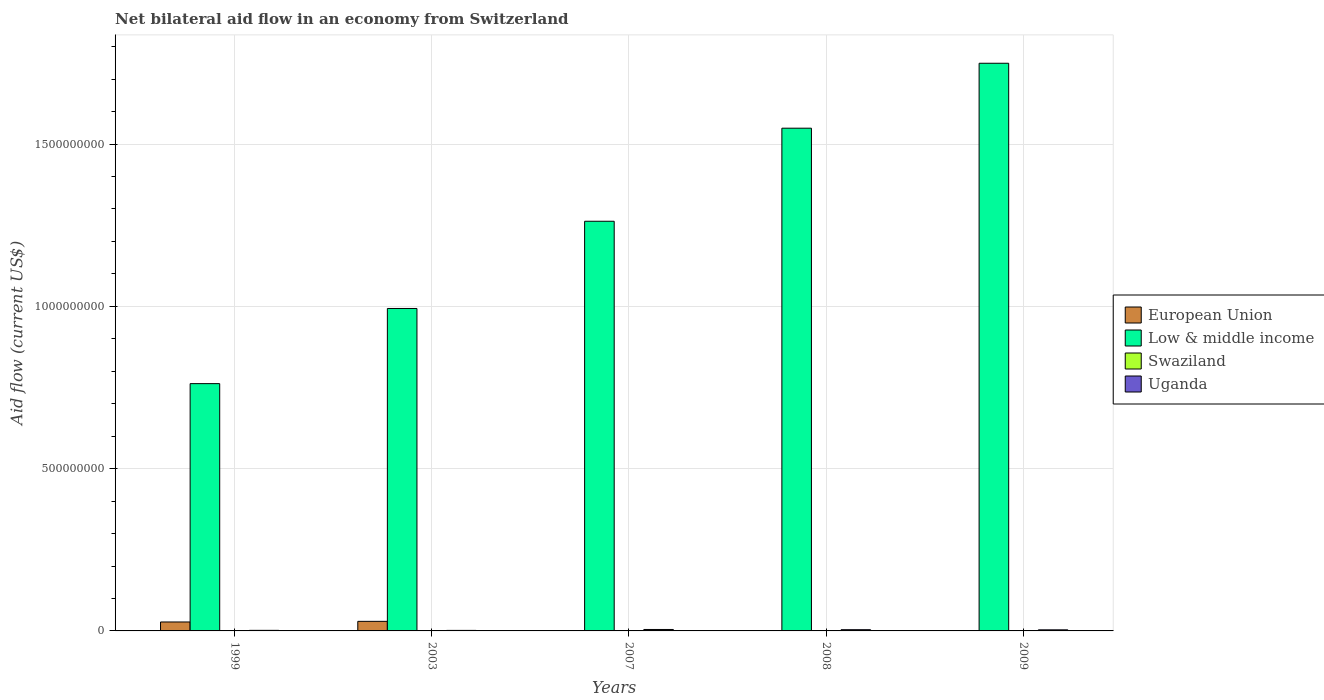Are the number of bars per tick equal to the number of legend labels?
Offer a terse response. Yes. Are the number of bars on each tick of the X-axis equal?
Offer a very short reply. Yes. How many bars are there on the 5th tick from the left?
Offer a very short reply. 4. In how many cases, is the number of bars for a given year not equal to the number of legend labels?
Ensure brevity in your answer.  0. Across all years, what is the maximum net bilateral aid flow in Low & middle income?
Keep it short and to the point. 1.75e+09. In which year was the net bilateral aid flow in Swaziland maximum?
Provide a succinct answer. 2008. What is the total net bilateral aid flow in Low & middle income in the graph?
Offer a very short reply. 6.32e+09. What is the difference between the net bilateral aid flow in Uganda in 2008 and that in 2009?
Give a very brief answer. 4.20e+05. What is the difference between the net bilateral aid flow in Low & middle income in 2003 and the net bilateral aid flow in Swaziland in 1999?
Ensure brevity in your answer.  9.93e+08. What is the average net bilateral aid flow in Low & middle income per year?
Keep it short and to the point. 1.26e+09. In the year 1999, what is the difference between the net bilateral aid flow in European Union and net bilateral aid flow in Uganda?
Make the answer very short. 2.58e+07. What is the ratio of the net bilateral aid flow in European Union in 1999 to that in 2007?
Offer a terse response. 306.33. Is the difference between the net bilateral aid flow in European Union in 1999 and 2008 greater than the difference between the net bilateral aid flow in Uganda in 1999 and 2008?
Offer a very short reply. Yes. What is the difference between the highest and the second highest net bilateral aid flow in Uganda?
Provide a short and direct response. 6.80e+05. What is the difference between the highest and the lowest net bilateral aid flow in Low & middle income?
Keep it short and to the point. 9.87e+08. In how many years, is the net bilateral aid flow in European Union greater than the average net bilateral aid flow in European Union taken over all years?
Offer a terse response. 2. Is the sum of the net bilateral aid flow in European Union in 2008 and 2009 greater than the maximum net bilateral aid flow in Low & middle income across all years?
Make the answer very short. No. What does the 3rd bar from the left in 2007 represents?
Offer a very short reply. Swaziland. What does the 1st bar from the right in 2009 represents?
Your answer should be compact. Uganda. Is it the case that in every year, the sum of the net bilateral aid flow in European Union and net bilateral aid flow in Swaziland is greater than the net bilateral aid flow in Uganda?
Offer a very short reply. No. How many bars are there?
Ensure brevity in your answer.  20. How many years are there in the graph?
Your answer should be compact. 5. What is the difference between two consecutive major ticks on the Y-axis?
Give a very brief answer. 5.00e+08. Does the graph contain grids?
Give a very brief answer. Yes. How many legend labels are there?
Your answer should be compact. 4. How are the legend labels stacked?
Offer a terse response. Vertical. What is the title of the graph?
Provide a short and direct response. Net bilateral aid flow in an economy from Switzerland. Does "Macedonia" appear as one of the legend labels in the graph?
Provide a succinct answer. No. What is the label or title of the Y-axis?
Provide a succinct answer. Aid flow (current US$). What is the Aid flow (current US$) in European Union in 1999?
Provide a succinct answer. 2.76e+07. What is the Aid flow (current US$) in Low & middle income in 1999?
Offer a terse response. 7.62e+08. What is the Aid flow (current US$) of Uganda in 1999?
Offer a terse response. 1.77e+06. What is the Aid flow (current US$) of European Union in 2003?
Provide a succinct answer. 2.95e+07. What is the Aid flow (current US$) of Low & middle income in 2003?
Your answer should be very brief. 9.93e+08. What is the Aid flow (current US$) in Uganda in 2003?
Your answer should be very brief. 1.62e+06. What is the Aid flow (current US$) in European Union in 2007?
Ensure brevity in your answer.  9.00e+04. What is the Aid flow (current US$) of Low & middle income in 2007?
Keep it short and to the point. 1.26e+09. What is the Aid flow (current US$) in Uganda in 2007?
Your answer should be compact. 4.44e+06. What is the Aid flow (current US$) in Low & middle income in 2008?
Give a very brief answer. 1.55e+09. What is the Aid flow (current US$) of Uganda in 2008?
Your answer should be very brief. 3.76e+06. What is the Aid flow (current US$) in European Union in 2009?
Provide a succinct answer. 8.00e+04. What is the Aid flow (current US$) of Low & middle income in 2009?
Your answer should be compact. 1.75e+09. What is the Aid flow (current US$) of Uganda in 2009?
Make the answer very short. 3.34e+06. Across all years, what is the maximum Aid flow (current US$) of European Union?
Your answer should be compact. 2.95e+07. Across all years, what is the maximum Aid flow (current US$) in Low & middle income?
Ensure brevity in your answer.  1.75e+09. Across all years, what is the maximum Aid flow (current US$) in Swaziland?
Give a very brief answer. 1.40e+05. Across all years, what is the maximum Aid flow (current US$) in Uganda?
Provide a succinct answer. 4.44e+06. Across all years, what is the minimum Aid flow (current US$) of European Union?
Provide a short and direct response. 8.00e+04. Across all years, what is the minimum Aid flow (current US$) of Low & middle income?
Your answer should be very brief. 7.62e+08. Across all years, what is the minimum Aid flow (current US$) in Swaziland?
Provide a succinct answer. 2.00e+04. Across all years, what is the minimum Aid flow (current US$) in Uganda?
Your answer should be compact. 1.62e+06. What is the total Aid flow (current US$) in European Union in the graph?
Keep it short and to the point. 5.74e+07. What is the total Aid flow (current US$) in Low & middle income in the graph?
Ensure brevity in your answer.  6.32e+09. What is the total Aid flow (current US$) in Swaziland in the graph?
Offer a terse response. 2.90e+05. What is the total Aid flow (current US$) in Uganda in the graph?
Keep it short and to the point. 1.49e+07. What is the difference between the Aid flow (current US$) in European Union in 1999 and that in 2003?
Your answer should be compact. -1.92e+06. What is the difference between the Aid flow (current US$) of Low & middle income in 1999 and that in 2003?
Your answer should be compact. -2.32e+08. What is the difference between the Aid flow (current US$) in European Union in 1999 and that in 2007?
Give a very brief answer. 2.75e+07. What is the difference between the Aid flow (current US$) of Low & middle income in 1999 and that in 2007?
Offer a very short reply. -5.00e+08. What is the difference between the Aid flow (current US$) of Uganda in 1999 and that in 2007?
Give a very brief answer. -2.67e+06. What is the difference between the Aid flow (current US$) of European Union in 1999 and that in 2008?
Give a very brief answer. 2.74e+07. What is the difference between the Aid flow (current US$) in Low & middle income in 1999 and that in 2008?
Provide a succinct answer. -7.87e+08. What is the difference between the Aid flow (current US$) of Swaziland in 1999 and that in 2008?
Provide a succinct answer. -1.00e+05. What is the difference between the Aid flow (current US$) of Uganda in 1999 and that in 2008?
Your answer should be very brief. -1.99e+06. What is the difference between the Aid flow (current US$) of European Union in 1999 and that in 2009?
Give a very brief answer. 2.75e+07. What is the difference between the Aid flow (current US$) of Low & middle income in 1999 and that in 2009?
Your answer should be compact. -9.87e+08. What is the difference between the Aid flow (current US$) in Swaziland in 1999 and that in 2009?
Your answer should be very brief. 2.00e+04. What is the difference between the Aid flow (current US$) in Uganda in 1999 and that in 2009?
Make the answer very short. -1.57e+06. What is the difference between the Aid flow (current US$) of European Union in 2003 and that in 2007?
Give a very brief answer. 2.94e+07. What is the difference between the Aid flow (current US$) of Low & middle income in 2003 and that in 2007?
Your answer should be very brief. -2.69e+08. What is the difference between the Aid flow (current US$) in Uganda in 2003 and that in 2007?
Offer a terse response. -2.82e+06. What is the difference between the Aid flow (current US$) in European Union in 2003 and that in 2008?
Keep it short and to the point. 2.94e+07. What is the difference between the Aid flow (current US$) of Low & middle income in 2003 and that in 2008?
Make the answer very short. -5.55e+08. What is the difference between the Aid flow (current US$) in Uganda in 2003 and that in 2008?
Keep it short and to the point. -2.14e+06. What is the difference between the Aid flow (current US$) of European Union in 2003 and that in 2009?
Your answer should be compact. 2.94e+07. What is the difference between the Aid flow (current US$) in Low & middle income in 2003 and that in 2009?
Offer a terse response. -7.56e+08. What is the difference between the Aid flow (current US$) of Uganda in 2003 and that in 2009?
Provide a short and direct response. -1.72e+06. What is the difference between the Aid flow (current US$) in Low & middle income in 2007 and that in 2008?
Your response must be concise. -2.87e+08. What is the difference between the Aid flow (current US$) in Swaziland in 2007 and that in 2008?
Ensure brevity in your answer.  -1.20e+05. What is the difference between the Aid flow (current US$) of Uganda in 2007 and that in 2008?
Your answer should be very brief. 6.80e+05. What is the difference between the Aid flow (current US$) of Low & middle income in 2007 and that in 2009?
Give a very brief answer. -4.87e+08. What is the difference between the Aid flow (current US$) of Swaziland in 2007 and that in 2009?
Provide a succinct answer. 0. What is the difference between the Aid flow (current US$) in Uganda in 2007 and that in 2009?
Ensure brevity in your answer.  1.10e+06. What is the difference between the Aid flow (current US$) in European Union in 2008 and that in 2009?
Provide a succinct answer. 5.00e+04. What is the difference between the Aid flow (current US$) of Low & middle income in 2008 and that in 2009?
Make the answer very short. -2.00e+08. What is the difference between the Aid flow (current US$) of Swaziland in 2008 and that in 2009?
Your response must be concise. 1.20e+05. What is the difference between the Aid flow (current US$) of European Union in 1999 and the Aid flow (current US$) of Low & middle income in 2003?
Keep it short and to the point. -9.66e+08. What is the difference between the Aid flow (current US$) in European Union in 1999 and the Aid flow (current US$) in Swaziland in 2003?
Your answer should be very brief. 2.75e+07. What is the difference between the Aid flow (current US$) in European Union in 1999 and the Aid flow (current US$) in Uganda in 2003?
Keep it short and to the point. 2.60e+07. What is the difference between the Aid flow (current US$) of Low & middle income in 1999 and the Aid flow (current US$) of Swaziland in 2003?
Your answer should be compact. 7.62e+08. What is the difference between the Aid flow (current US$) in Low & middle income in 1999 and the Aid flow (current US$) in Uganda in 2003?
Your response must be concise. 7.60e+08. What is the difference between the Aid flow (current US$) of Swaziland in 1999 and the Aid flow (current US$) of Uganda in 2003?
Offer a terse response. -1.58e+06. What is the difference between the Aid flow (current US$) of European Union in 1999 and the Aid flow (current US$) of Low & middle income in 2007?
Ensure brevity in your answer.  -1.23e+09. What is the difference between the Aid flow (current US$) of European Union in 1999 and the Aid flow (current US$) of Swaziland in 2007?
Make the answer very short. 2.76e+07. What is the difference between the Aid flow (current US$) of European Union in 1999 and the Aid flow (current US$) of Uganda in 2007?
Offer a very short reply. 2.31e+07. What is the difference between the Aid flow (current US$) in Low & middle income in 1999 and the Aid flow (current US$) in Swaziland in 2007?
Keep it short and to the point. 7.62e+08. What is the difference between the Aid flow (current US$) of Low & middle income in 1999 and the Aid flow (current US$) of Uganda in 2007?
Offer a very short reply. 7.57e+08. What is the difference between the Aid flow (current US$) of Swaziland in 1999 and the Aid flow (current US$) of Uganda in 2007?
Provide a succinct answer. -4.40e+06. What is the difference between the Aid flow (current US$) in European Union in 1999 and the Aid flow (current US$) in Low & middle income in 2008?
Your answer should be compact. -1.52e+09. What is the difference between the Aid flow (current US$) in European Union in 1999 and the Aid flow (current US$) in Swaziland in 2008?
Give a very brief answer. 2.74e+07. What is the difference between the Aid flow (current US$) in European Union in 1999 and the Aid flow (current US$) in Uganda in 2008?
Your answer should be compact. 2.38e+07. What is the difference between the Aid flow (current US$) in Low & middle income in 1999 and the Aid flow (current US$) in Swaziland in 2008?
Give a very brief answer. 7.62e+08. What is the difference between the Aid flow (current US$) in Low & middle income in 1999 and the Aid flow (current US$) in Uganda in 2008?
Provide a succinct answer. 7.58e+08. What is the difference between the Aid flow (current US$) in Swaziland in 1999 and the Aid flow (current US$) in Uganda in 2008?
Provide a succinct answer. -3.72e+06. What is the difference between the Aid flow (current US$) in European Union in 1999 and the Aid flow (current US$) in Low & middle income in 2009?
Provide a short and direct response. -1.72e+09. What is the difference between the Aid flow (current US$) of European Union in 1999 and the Aid flow (current US$) of Swaziland in 2009?
Your response must be concise. 2.76e+07. What is the difference between the Aid flow (current US$) of European Union in 1999 and the Aid flow (current US$) of Uganda in 2009?
Your response must be concise. 2.42e+07. What is the difference between the Aid flow (current US$) in Low & middle income in 1999 and the Aid flow (current US$) in Swaziland in 2009?
Your answer should be very brief. 7.62e+08. What is the difference between the Aid flow (current US$) in Low & middle income in 1999 and the Aid flow (current US$) in Uganda in 2009?
Make the answer very short. 7.59e+08. What is the difference between the Aid flow (current US$) in Swaziland in 1999 and the Aid flow (current US$) in Uganda in 2009?
Make the answer very short. -3.30e+06. What is the difference between the Aid flow (current US$) of European Union in 2003 and the Aid flow (current US$) of Low & middle income in 2007?
Your answer should be very brief. -1.23e+09. What is the difference between the Aid flow (current US$) in European Union in 2003 and the Aid flow (current US$) in Swaziland in 2007?
Your answer should be very brief. 2.95e+07. What is the difference between the Aid flow (current US$) of European Union in 2003 and the Aid flow (current US$) of Uganda in 2007?
Offer a very short reply. 2.50e+07. What is the difference between the Aid flow (current US$) in Low & middle income in 2003 and the Aid flow (current US$) in Swaziland in 2007?
Keep it short and to the point. 9.93e+08. What is the difference between the Aid flow (current US$) in Low & middle income in 2003 and the Aid flow (current US$) in Uganda in 2007?
Offer a terse response. 9.89e+08. What is the difference between the Aid flow (current US$) in Swaziland in 2003 and the Aid flow (current US$) in Uganda in 2007?
Give a very brief answer. -4.37e+06. What is the difference between the Aid flow (current US$) in European Union in 2003 and the Aid flow (current US$) in Low & middle income in 2008?
Your answer should be compact. -1.52e+09. What is the difference between the Aid flow (current US$) in European Union in 2003 and the Aid flow (current US$) in Swaziland in 2008?
Make the answer very short. 2.94e+07. What is the difference between the Aid flow (current US$) of European Union in 2003 and the Aid flow (current US$) of Uganda in 2008?
Your answer should be compact. 2.57e+07. What is the difference between the Aid flow (current US$) in Low & middle income in 2003 and the Aid flow (current US$) in Swaziland in 2008?
Offer a very short reply. 9.93e+08. What is the difference between the Aid flow (current US$) of Low & middle income in 2003 and the Aid flow (current US$) of Uganda in 2008?
Give a very brief answer. 9.90e+08. What is the difference between the Aid flow (current US$) in Swaziland in 2003 and the Aid flow (current US$) in Uganda in 2008?
Make the answer very short. -3.69e+06. What is the difference between the Aid flow (current US$) of European Union in 2003 and the Aid flow (current US$) of Low & middle income in 2009?
Offer a terse response. -1.72e+09. What is the difference between the Aid flow (current US$) of European Union in 2003 and the Aid flow (current US$) of Swaziland in 2009?
Provide a succinct answer. 2.95e+07. What is the difference between the Aid flow (current US$) of European Union in 2003 and the Aid flow (current US$) of Uganda in 2009?
Offer a very short reply. 2.62e+07. What is the difference between the Aid flow (current US$) of Low & middle income in 2003 and the Aid flow (current US$) of Swaziland in 2009?
Ensure brevity in your answer.  9.93e+08. What is the difference between the Aid flow (current US$) of Low & middle income in 2003 and the Aid flow (current US$) of Uganda in 2009?
Make the answer very short. 9.90e+08. What is the difference between the Aid flow (current US$) of Swaziland in 2003 and the Aid flow (current US$) of Uganda in 2009?
Offer a very short reply. -3.27e+06. What is the difference between the Aid flow (current US$) in European Union in 2007 and the Aid flow (current US$) in Low & middle income in 2008?
Offer a terse response. -1.55e+09. What is the difference between the Aid flow (current US$) of European Union in 2007 and the Aid flow (current US$) of Uganda in 2008?
Your answer should be compact. -3.67e+06. What is the difference between the Aid flow (current US$) in Low & middle income in 2007 and the Aid flow (current US$) in Swaziland in 2008?
Provide a succinct answer. 1.26e+09. What is the difference between the Aid flow (current US$) of Low & middle income in 2007 and the Aid flow (current US$) of Uganda in 2008?
Keep it short and to the point. 1.26e+09. What is the difference between the Aid flow (current US$) in Swaziland in 2007 and the Aid flow (current US$) in Uganda in 2008?
Give a very brief answer. -3.74e+06. What is the difference between the Aid flow (current US$) of European Union in 2007 and the Aid flow (current US$) of Low & middle income in 2009?
Your answer should be very brief. -1.75e+09. What is the difference between the Aid flow (current US$) of European Union in 2007 and the Aid flow (current US$) of Uganda in 2009?
Provide a short and direct response. -3.25e+06. What is the difference between the Aid flow (current US$) in Low & middle income in 2007 and the Aid flow (current US$) in Swaziland in 2009?
Offer a very short reply. 1.26e+09. What is the difference between the Aid flow (current US$) of Low & middle income in 2007 and the Aid flow (current US$) of Uganda in 2009?
Give a very brief answer. 1.26e+09. What is the difference between the Aid flow (current US$) in Swaziland in 2007 and the Aid flow (current US$) in Uganda in 2009?
Keep it short and to the point. -3.32e+06. What is the difference between the Aid flow (current US$) in European Union in 2008 and the Aid flow (current US$) in Low & middle income in 2009?
Your answer should be very brief. -1.75e+09. What is the difference between the Aid flow (current US$) of European Union in 2008 and the Aid flow (current US$) of Swaziland in 2009?
Your answer should be compact. 1.10e+05. What is the difference between the Aid flow (current US$) of European Union in 2008 and the Aid flow (current US$) of Uganda in 2009?
Offer a very short reply. -3.21e+06. What is the difference between the Aid flow (current US$) in Low & middle income in 2008 and the Aid flow (current US$) in Swaziland in 2009?
Offer a terse response. 1.55e+09. What is the difference between the Aid flow (current US$) in Low & middle income in 2008 and the Aid flow (current US$) in Uganda in 2009?
Your answer should be compact. 1.55e+09. What is the difference between the Aid flow (current US$) of Swaziland in 2008 and the Aid flow (current US$) of Uganda in 2009?
Give a very brief answer. -3.20e+06. What is the average Aid flow (current US$) of European Union per year?
Provide a succinct answer. 1.15e+07. What is the average Aid flow (current US$) in Low & middle income per year?
Your answer should be very brief. 1.26e+09. What is the average Aid flow (current US$) in Swaziland per year?
Make the answer very short. 5.80e+04. What is the average Aid flow (current US$) in Uganda per year?
Ensure brevity in your answer.  2.99e+06. In the year 1999, what is the difference between the Aid flow (current US$) in European Union and Aid flow (current US$) in Low & middle income?
Your answer should be very brief. -7.34e+08. In the year 1999, what is the difference between the Aid flow (current US$) of European Union and Aid flow (current US$) of Swaziland?
Ensure brevity in your answer.  2.75e+07. In the year 1999, what is the difference between the Aid flow (current US$) in European Union and Aid flow (current US$) in Uganda?
Ensure brevity in your answer.  2.58e+07. In the year 1999, what is the difference between the Aid flow (current US$) of Low & middle income and Aid flow (current US$) of Swaziland?
Keep it short and to the point. 7.62e+08. In the year 1999, what is the difference between the Aid flow (current US$) in Low & middle income and Aid flow (current US$) in Uganda?
Provide a short and direct response. 7.60e+08. In the year 1999, what is the difference between the Aid flow (current US$) of Swaziland and Aid flow (current US$) of Uganda?
Provide a short and direct response. -1.73e+06. In the year 2003, what is the difference between the Aid flow (current US$) in European Union and Aid flow (current US$) in Low & middle income?
Your response must be concise. -9.64e+08. In the year 2003, what is the difference between the Aid flow (current US$) in European Union and Aid flow (current US$) in Swaziland?
Your answer should be very brief. 2.94e+07. In the year 2003, what is the difference between the Aid flow (current US$) in European Union and Aid flow (current US$) in Uganda?
Provide a short and direct response. 2.79e+07. In the year 2003, what is the difference between the Aid flow (current US$) in Low & middle income and Aid flow (current US$) in Swaziland?
Your answer should be compact. 9.93e+08. In the year 2003, what is the difference between the Aid flow (current US$) of Low & middle income and Aid flow (current US$) of Uganda?
Offer a very short reply. 9.92e+08. In the year 2003, what is the difference between the Aid flow (current US$) in Swaziland and Aid flow (current US$) in Uganda?
Give a very brief answer. -1.55e+06. In the year 2007, what is the difference between the Aid flow (current US$) in European Union and Aid flow (current US$) in Low & middle income?
Keep it short and to the point. -1.26e+09. In the year 2007, what is the difference between the Aid flow (current US$) of European Union and Aid flow (current US$) of Swaziland?
Offer a very short reply. 7.00e+04. In the year 2007, what is the difference between the Aid flow (current US$) in European Union and Aid flow (current US$) in Uganda?
Your response must be concise. -4.35e+06. In the year 2007, what is the difference between the Aid flow (current US$) of Low & middle income and Aid flow (current US$) of Swaziland?
Give a very brief answer. 1.26e+09. In the year 2007, what is the difference between the Aid flow (current US$) of Low & middle income and Aid flow (current US$) of Uganda?
Ensure brevity in your answer.  1.26e+09. In the year 2007, what is the difference between the Aid flow (current US$) of Swaziland and Aid flow (current US$) of Uganda?
Provide a short and direct response. -4.42e+06. In the year 2008, what is the difference between the Aid flow (current US$) in European Union and Aid flow (current US$) in Low & middle income?
Provide a short and direct response. -1.55e+09. In the year 2008, what is the difference between the Aid flow (current US$) in European Union and Aid flow (current US$) in Uganda?
Keep it short and to the point. -3.63e+06. In the year 2008, what is the difference between the Aid flow (current US$) of Low & middle income and Aid flow (current US$) of Swaziland?
Your response must be concise. 1.55e+09. In the year 2008, what is the difference between the Aid flow (current US$) in Low & middle income and Aid flow (current US$) in Uganda?
Your answer should be compact. 1.55e+09. In the year 2008, what is the difference between the Aid flow (current US$) in Swaziland and Aid flow (current US$) in Uganda?
Give a very brief answer. -3.62e+06. In the year 2009, what is the difference between the Aid flow (current US$) in European Union and Aid flow (current US$) in Low & middle income?
Keep it short and to the point. -1.75e+09. In the year 2009, what is the difference between the Aid flow (current US$) in European Union and Aid flow (current US$) in Uganda?
Give a very brief answer. -3.26e+06. In the year 2009, what is the difference between the Aid flow (current US$) in Low & middle income and Aid flow (current US$) in Swaziland?
Offer a very short reply. 1.75e+09. In the year 2009, what is the difference between the Aid flow (current US$) of Low & middle income and Aid flow (current US$) of Uganda?
Make the answer very short. 1.75e+09. In the year 2009, what is the difference between the Aid flow (current US$) of Swaziland and Aid flow (current US$) of Uganda?
Ensure brevity in your answer.  -3.32e+06. What is the ratio of the Aid flow (current US$) of European Union in 1999 to that in 2003?
Provide a short and direct response. 0.93. What is the ratio of the Aid flow (current US$) of Low & middle income in 1999 to that in 2003?
Ensure brevity in your answer.  0.77. What is the ratio of the Aid flow (current US$) of Uganda in 1999 to that in 2003?
Provide a short and direct response. 1.09. What is the ratio of the Aid flow (current US$) in European Union in 1999 to that in 2007?
Provide a succinct answer. 306.33. What is the ratio of the Aid flow (current US$) of Low & middle income in 1999 to that in 2007?
Make the answer very short. 0.6. What is the ratio of the Aid flow (current US$) in Swaziland in 1999 to that in 2007?
Offer a terse response. 2. What is the ratio of the Aid flow (current US$) of Uganda in 1999 to that in 2007?
Your response must be concise. 0.4. What is the ratio of the Aid flow (current US$) of European Union in 1999 to that in 2008?
Provide a succinct answer. 212.08. What is the ratio of the Aid flow (current US$) of Low & middle income in 1999 to that in 2008?
Offer a terse response. 0.49. What is the ratio of the Aid flow (current US$) of Swaziland in 1999 to that in 2008?
Your response must be concise. 0.29. What is the ratio of the Aid flow (current US$) of Uganda in 1999 to that in 2008?
Ensure brevity in your answer.  0.47. What is the ratio of the Aid flow (current US$) in European Union in 1999 to that in 2009?
Keep it short and to the point. 344.62. What is the ratio of the Aid flow (current US$) in Low & middle income in 1999 to that in 2009?
Your response must be concise. 0.44. What is the ratio of the Aid flow (current US$) of Uganda in 1999 to that in 2009?
Provide a succinct answer. 0.53. What is the ratio of the Aid flow (current US$) in European Union in 2003 to that in 2007?
Offer a very short reply. 327.67. What is the ratio of the Aid flow (current US$) in Low & middle income in 2003 to that in 2007?
Offer a very short reply. 0.79. What is the ratio of the Aid flow (current US$) in Uganda in 2003 to that in 2007?
Ensure brevity in your answer.  0.36. What is the ratio of the Aid flow (current US$) in European Union in 2003 to that in 2008?
Keep it short and to the point. 226.85. What is the ratio of the Aid flow (current US$) of Low & middle income in 2003 to that in 2008?
Offer a terse response. 0.64. What is the ratio of the Aid flow (current US$) in Swaziland in 2003 to that in 2008?
Your answer should be very brief. 0.5. What is the ratio of the Aid flow (current US$) in Uganda in 2003 to that in 2008?
Provide a short and direct response. 0.43. What is the ratio of the Aid flow (current US$) in European Union in 2003 to that in 2009?
Provide a short and direct response. 368.62. What is the ratio of the Aid flow (current US$) of Low & middle income in 2003 to that in 2009?
Offer a terse response. 0.57. What is the ratio of the Aid flow (current US$) of Swaziland in 2003 to that in 2009?
Keep it short and to the point. 3.5. What is the ratio of the Aid flow (current US$) in Uganda in 2003 to that in 2009?
Give a very brief answer. 0.48. What is the ratio of the Aid flow (current US$) of European Union in 2007 to that in 2008?
Your answer should be very brief. 0.69. What is the ratio of the Aid flow (current US$) of Low & middle income in 2007 to that in 2008?
Offer a very short reply. 0.81. What is the ratio of the Aid flow (current US$) in Swaziland in 2007 to that in 2008?
Make the answer very short. 0.14. What is the ratio of the Aid flow (current US$) of Uganda in 2007 to that in 2008?
Keep it short and to the point. 1.18. What is the ratio of the Aid flow (current US$) of European Union in 2007 to that in 2009?
Make the answer very short. 1.12. What is the ratio of the Aid flow (current US$) of Low & middle income in 2007 to that in 2009?
Provide a short and direct response. 0.72. What is the ratio of the Aid flow (current US$) of Uganda in 2007 to that in 2009?
Give a very brief answer. 1.33. What is the ratio of the Aid flow (current US$) in European Union in 2008 to that in 2009?
Offer a very short reply. 1.62. What is the ratio of the Aid flow (current US$) of Low & middle income in 2008 to that in 2009?
Provide a short and direct response. 0.89. What is the ratio of the Aid flow (current US$) of Uganda in 2008 to that in 2009?
Keep it short and to the point. 1.13. What is the difference between the highest and the second highest Aid flow (current US$) of European Union?
Your answer should be compact. 1.92e+06. What is the difference between the highest and the second highest Aid flow (current US$) in Low & middle income?
Your answer should be very brief. 2.00e+08. What is the difference between the highest and the second highest Aid flow (current US$) of Uganda?
Your answer should be very brief. 6.80e+05. What is the difference between the highest and the lowest Aid flow (current US$) of European Union?
Your answer should be very brief. 2.94e+07. What is the difference between the highest and the lowest Aid flow (current US$) in Low & middle income?
Provide a succinct answer. 9.87e+08. What is the difference between the highest and the lowest Aid flow (current US$) in Swaziland?
Your response must be concise. 1.20e+05. What is the difference between the highest and the lowest Aid flow (current US$) of Uganda?
Offer a terse response. 2.82e+06. 